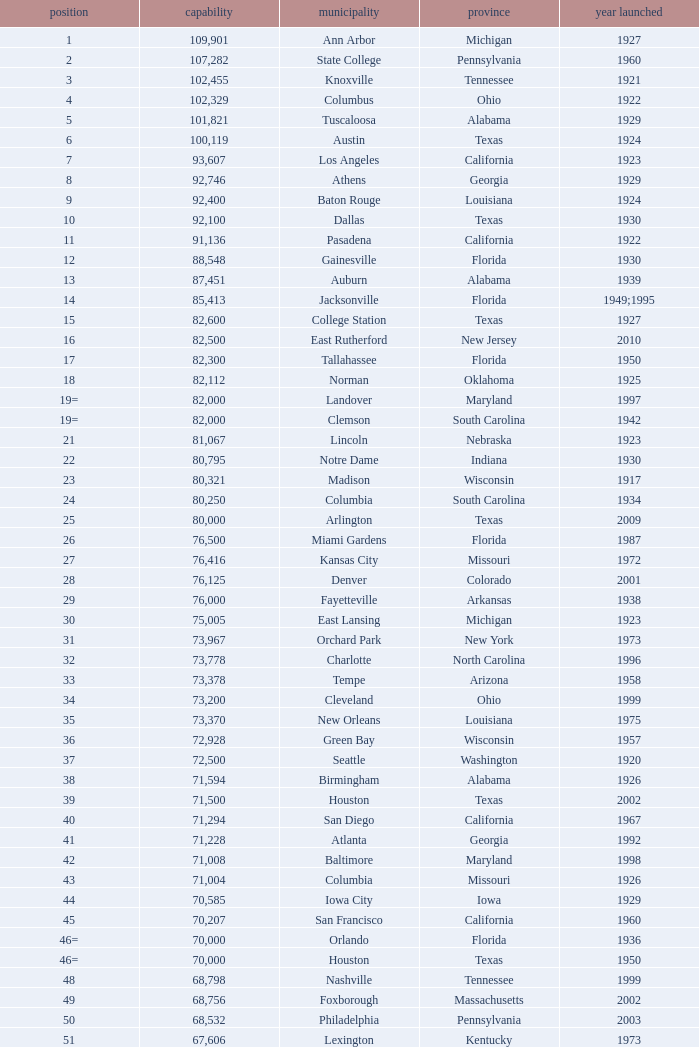What is the lowest capacity for 1903? 30323.0. 